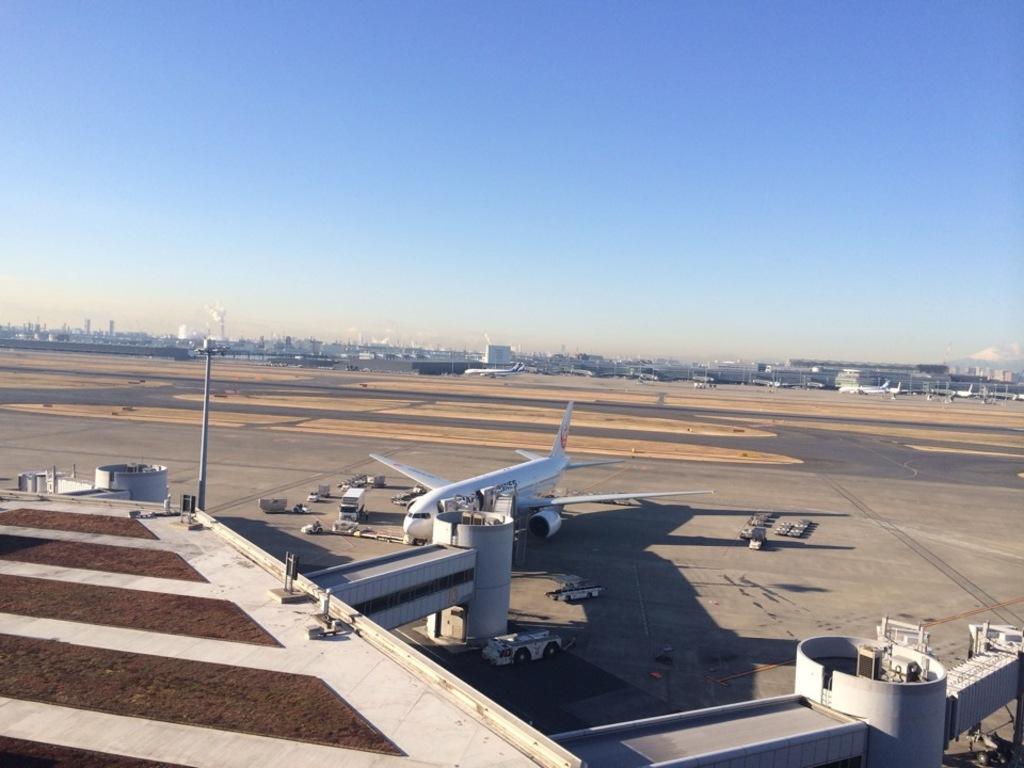Please provide a concise description of this image. In this image, we can see an aeroplane, few vehicles, pillars, pole. Background we can see few buildings and vehicles. Top of the image, there is a clear sky. 